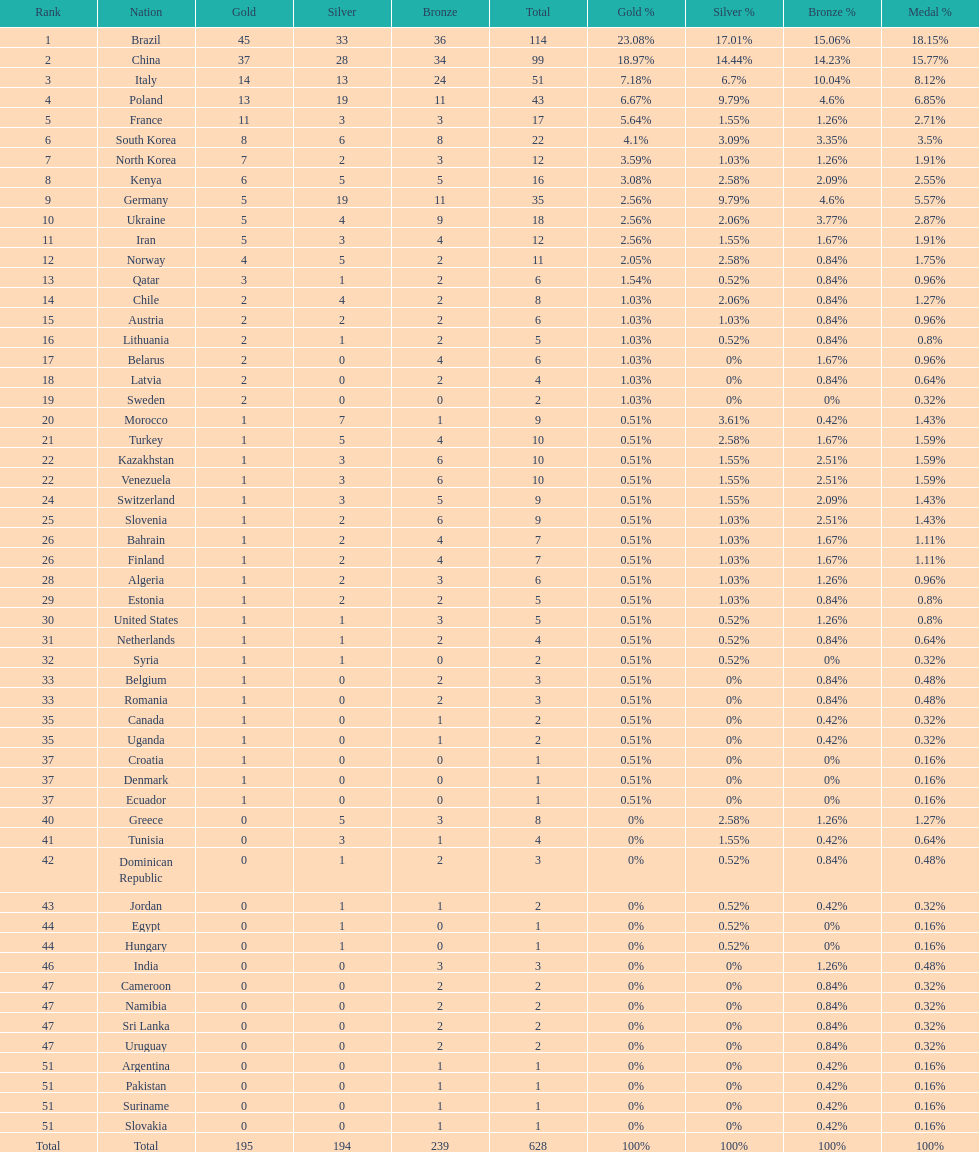Who won more gold medals, brazil or china? Brazil. 